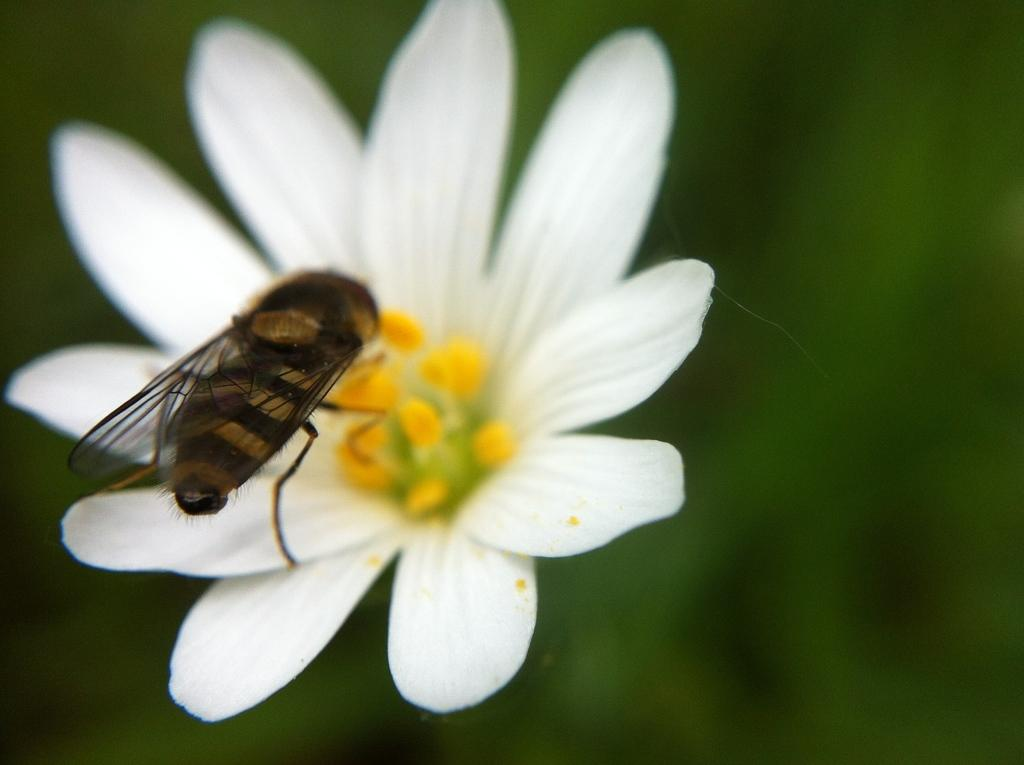What is present on the flower in the image? There is an insect on the flower in the image. What can be observed in the background of the image? The background of the image is green. What type of disease is the insect spreading in the image? There is no indication in the image that the insect is spreading any disease. 